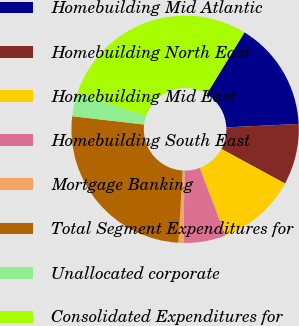Convert chart to OTSL. <chart><loc_0><loc_0><loc_500><loc_500><pie_chart><fcel>Homebuilding Mid Atlantic<fcel>Homebuilding North East<fcel>Homebuilding Mid East<fcel>Homebuilding South East<fcel>Mortgage Banking<fcel>Total Segment Expenditures for<fcel>Unallocated corporate<fcel>Consolidated Expenditures for<nl><fcel>15.51%<fcel>8.66%<fcel>11.31%<fcel>6.01%<fcel>0.71%<fcel>25.9%<fcel>3.36%<fcel>28.55%<nl></chart> 